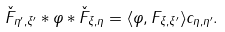<formula> <loc_0><loc_0><loc_500><loc_500>\check { F } _ { \eta ^ { \prime } , \xi ^ { \prime } } \ast \varphi \ast \check { F } _ { \xi , \eta } = \langle { \varphi } , F _ { \xi , \xi ^ { \prime } } \rangle c _ { \eta , \eta ^ { \prime } } .</formula> 